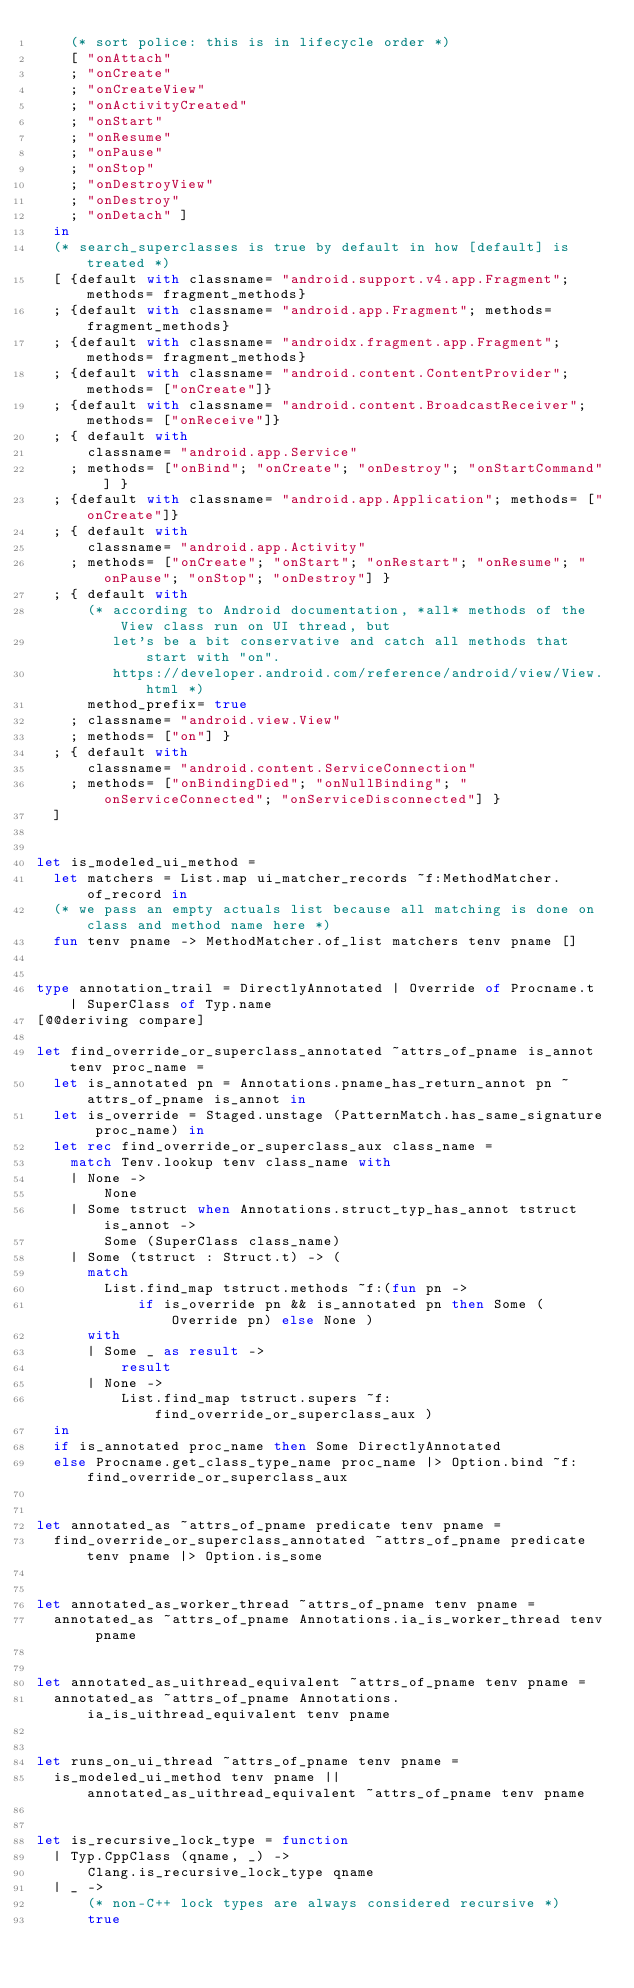<code> <loc_0><loc_0><loc_500><loc_500><_OCaml_>    (* sort police: this is in lifecycle order *)
    [ "onAttach"
    ; "onCreate"
    ; "onCreateView"
    ; "onActivityCreated"
    ; "onStart"
    ; "onResume"
    ; "onPause"
    ; "onStop"
    ; "onDestroyView"
    ; "onDestroy"
    ; "onDetach" ]
  in
  (* search_superclasses is true by default in how [default] is treated *)
  [ {default with classname= "android.support.v4.app.Fragment"; methods= fragment_methods}
  ; {default with classname= "android.app.Fragment"; methods= fragment_methods}
  ; {default with classname= "androidx.fragment.app.Fragment"; methods= fragment_methods}
  ; {default with classname= "android.content.ContentProvider"; methods= ["onCreate"]}
  ; {default with classname= "android.content.BroadcastReceiver"; methods= ["onReceive"]}
  ; { default with
      classname= "android.app.Service"
    ; methods= ["onBind"; "onCreate"; "onDestroy"; "onStartCommand"] }
  ; {default with classname= "android.app.Application"; methods= ["onCreate"]}
  ; { default with
      classname= "android.app.Activity"
    ; methods= ["onCreate"; "onStart"; "onRestart"; "onResume"; "onPause"; "onStop"; "onDestroy"] }
  ; { default with
      (* according to Android documentation, *all* methods of the View class run on UI thread, but
         let's be a bit conservative and catch all methods that start with "on".
         https://developer.android.com/reference/android/view/View.html *)
      method_prefix= true
    ; classname= "android.view.View"
    ; methods= ["on"] }
  ; { default with
      classname= "android.content.ServiceConnection"
    ; methods= ["onBindingDied"; "onNullBinding"; "onServiceConnected"; "onServiceDisconnected"] }
  ]


let is_modeled_ui_method =
  let matchers = List.map ui_matcher_records ~f:MethodMatcher.of_record in
  (* we pass an empty actuals list because all matching is done on class and method name here *)
  fun tenv pname -> MethodMatcher.of_list matchers tenv pname []


type annotation_trail = DirectlyAnnotated | Override of Procname.t | SuperClass of Typ.name
[@@deriving compare]

let find_override_or_superclass_annotated ~attrs_of_pname is_annot tenv proc_name =
  let is_annotated pn = Annotations.pname_has_return_annot pn ~attrs_of_pname is_annot in
  let is_override = Staged.unstage (PatternMatch.has_same_signature proc_name) in
  let rec find_override_or_superclass_aux class_name =
    match Tenv.lookup tenv class_name with
    | None ->
        None
    | Some tstruct when Annotations.struct_typ_has_annot tstruct is_annot ->
        Some (SuperClass class_name)
    | Some (tstruct : Struct.t) -> (
      match
        List.find_map tstruct.methods ~f:(fun pn ->
            if is_override pn && is_annotated pn then Some (Override pn) else None )
      with
      | Some _ as result ->
          result
      | None ->
          List.find_map tstruct.supers ~f:find_override_or_superclass_aux )
  in
  if is_annotated proc_name then Some DirectlyAnnotated
  else Procname.get_class_type_name proc_name |> Option.bind ~f:find_override_or_superclass_aux


let annotated_as ~attrs_of_pname predicate tenv pname =
  find_override_or_superclass_annotated ~attrs_of_pname predicate tenv pname |> Option.is_some


let annotated_as_worker_thread ~attrs_of_pname tenv pname =
  annotated_as ~attrs_of_pname Annotations.ia_is_worker_thread tenv pname


let annotated_as_uithread_equivalent ~attrs_of_pname tenv pname =
  annotated_as ~attrs_of_pname Annotations.ia_is_uithread_equivalent tenv pname


let runs_on_ui_thread ~attrs_of_pname tenv pname =
  is_modeled_ui_method tenv pname || annotated_as_uithread_equivalent ~attrs_of_pname tenv pname


let is_recursive_lock_type = function
  | Typ.CppClass (qname, _) ->
      Clang.is_recursive_lock_type qname
  | _ ->
      (* non-C++ lock types are always considered recursive *)
      true
</code> 